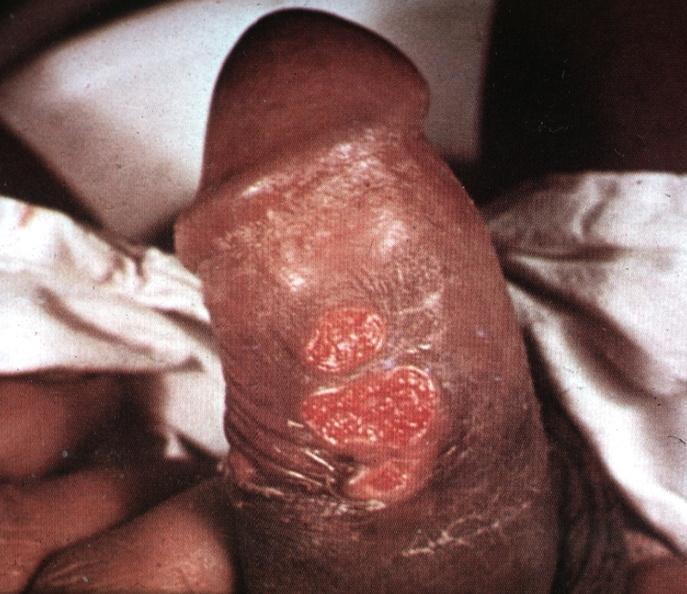what does this image show?
Answer the question using a single word or phrase. That ulcerative lesions slide is labeled chancroid 